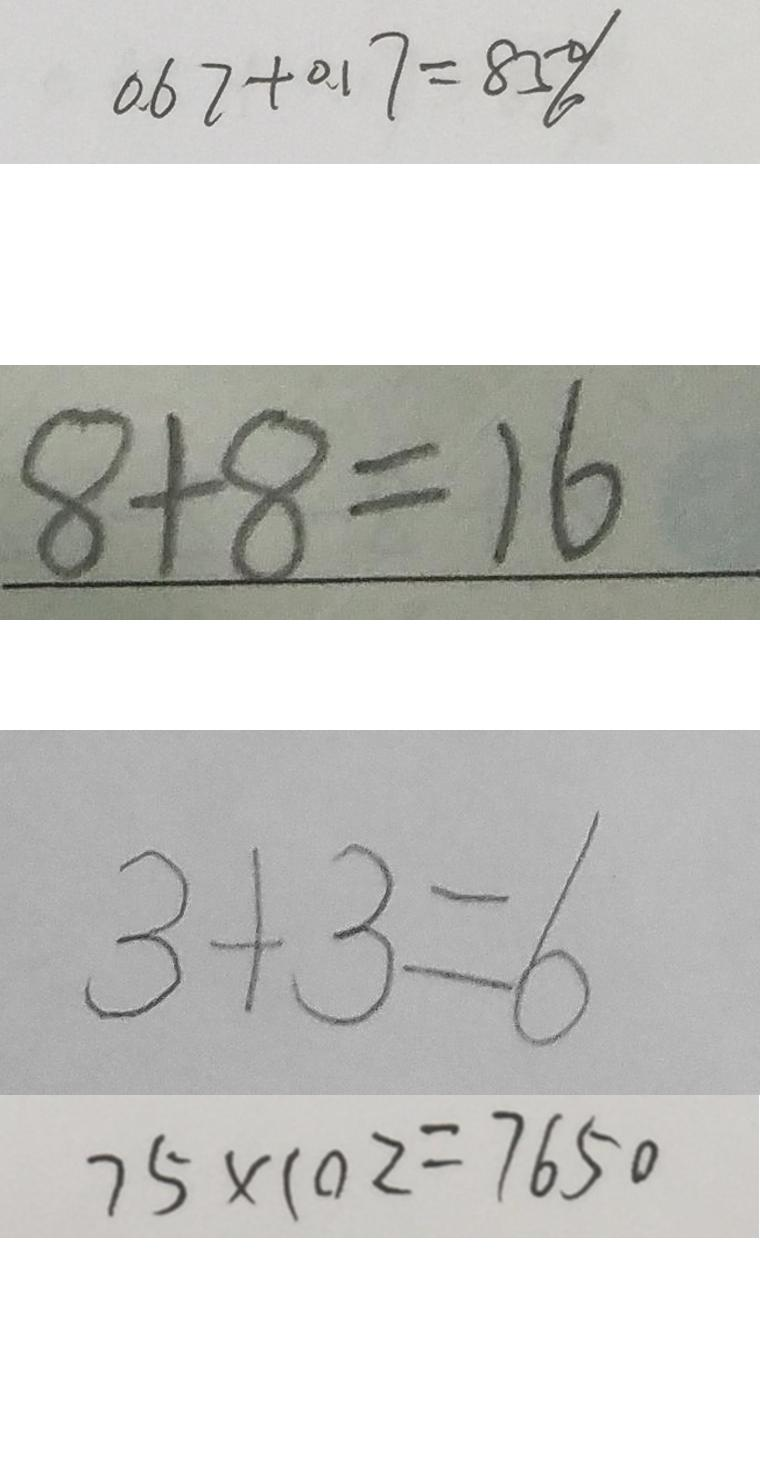<formula> <loc_0><loc_0><loc_500><loc_500>0 . 6 7 + 0 . 1 7 = 8 5 \% 
 8 + 8 = 1 6 
 3 + 3 = 6 
 7 5 \times 1 0 2 = 7 6 5 0</formula> 